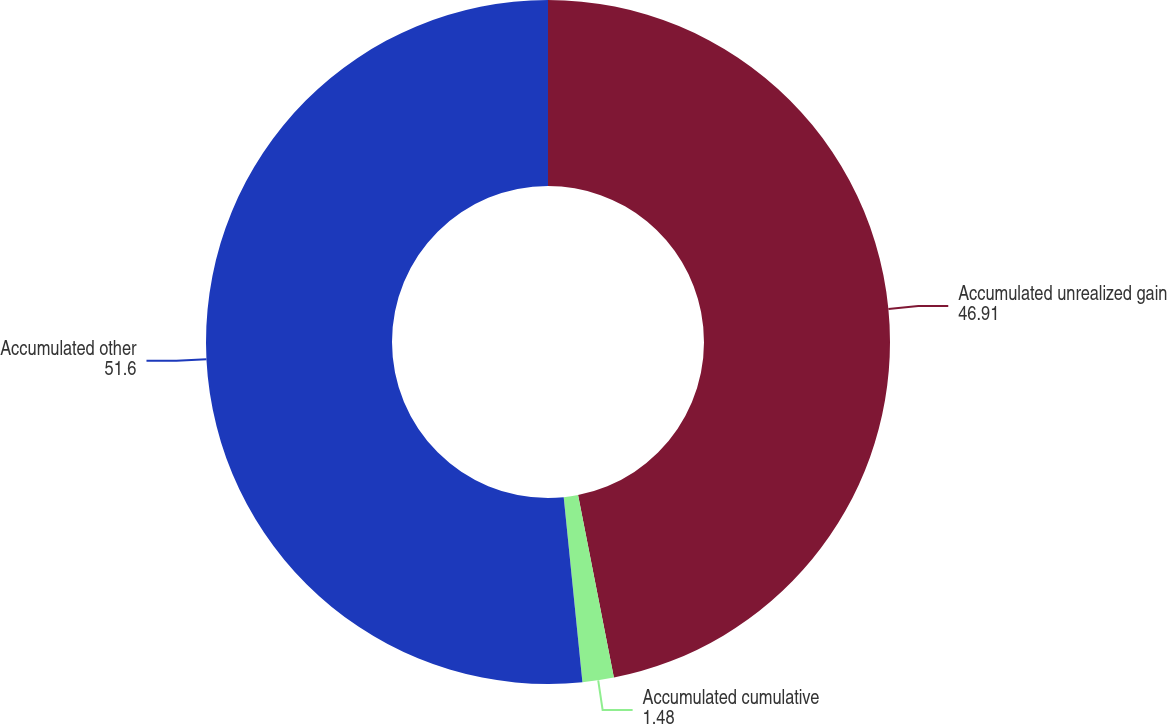Convert chart to OTSL. <chart><loc_0><loc_0><loc_500><loc_500><pie_chart><fcel>Accumulated unrealized gain<fcel>Accumulated cumulative<fcel>Accumulated other<nl><fcel>46.91%<fcel>1.48%<fcel>51.6%<nl></chart> 